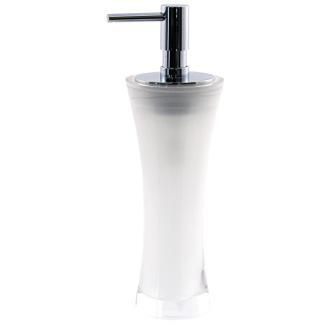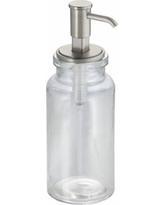The first image is the image on the left, the second image is the image on the right. Given the left and right images, does the statement "The nozzles of the dispensers in the left and right images face generally toward each other." hold true? Answer yes or no. No. The first image is the image on the left, the second image is the image on the right. Analyze the images presented: Is the assertion "The dispenser in the right photo has a transparent bottle." valid? Answer yes or no. Yes. 